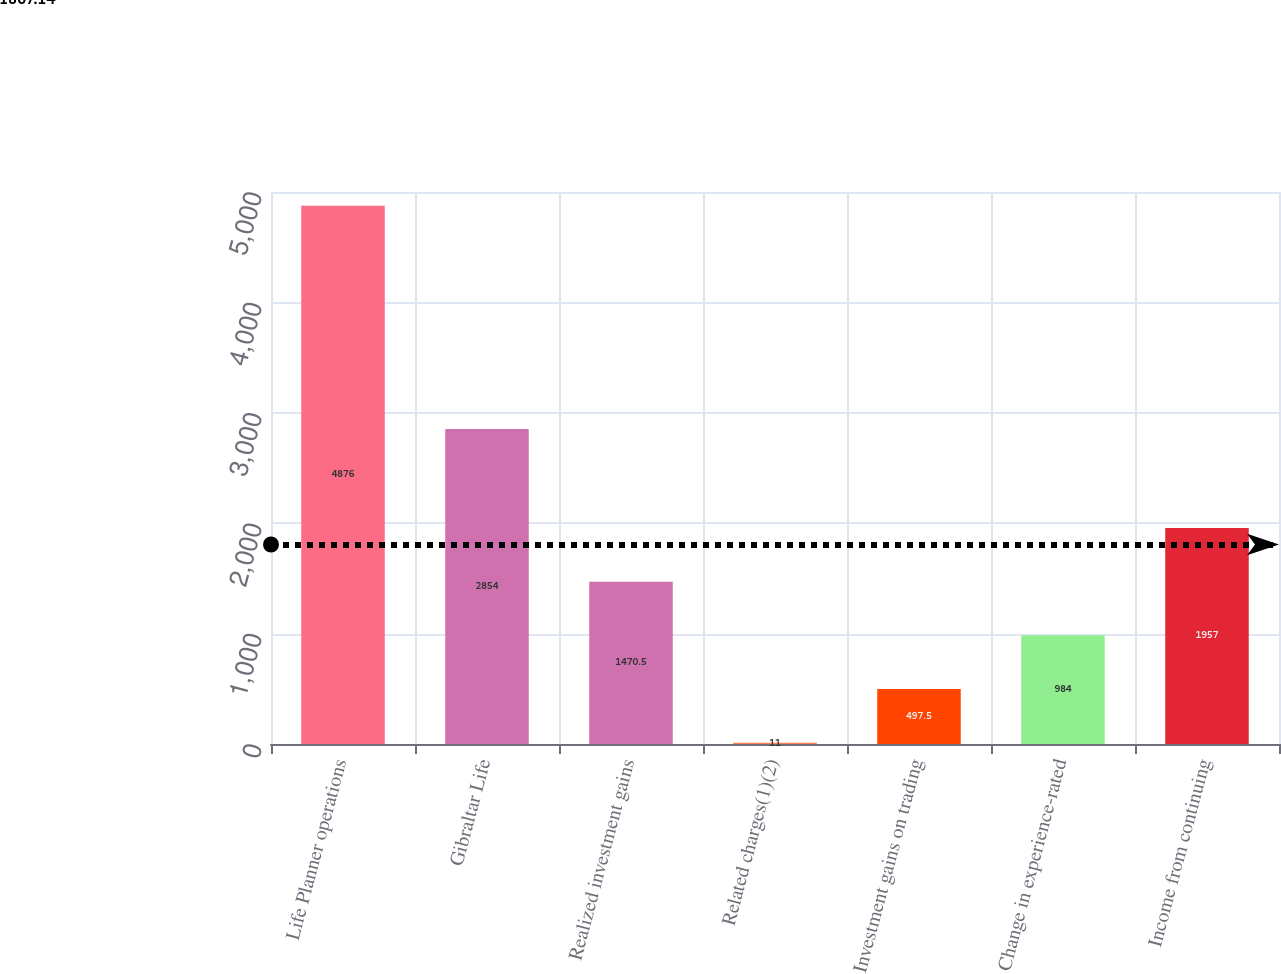<chart> <loc_0><loc_0><loc_500><loc_500><bar_chart><fcel>Life Planner operations<fcel>Gibraltar Life<fcel>Realized investment gains<fcel>Related charges(1)(2)<fcel>Investment gains on trading<fcel>Change in experience-rated<fcel>Income from continuing<nl><fcel>4876<fcel>2854<fcel>1470.5<fcel>11<fcel>497.5<fcel>984<fcel>1957<nl></chart> 